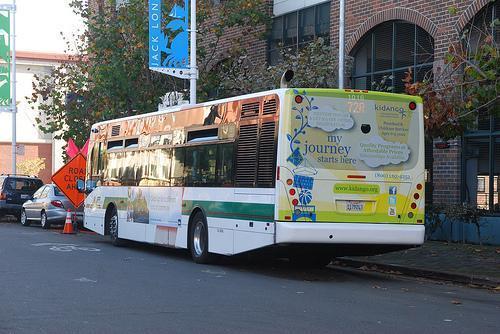How many buses are there?
Give a very brief answer. 1. 